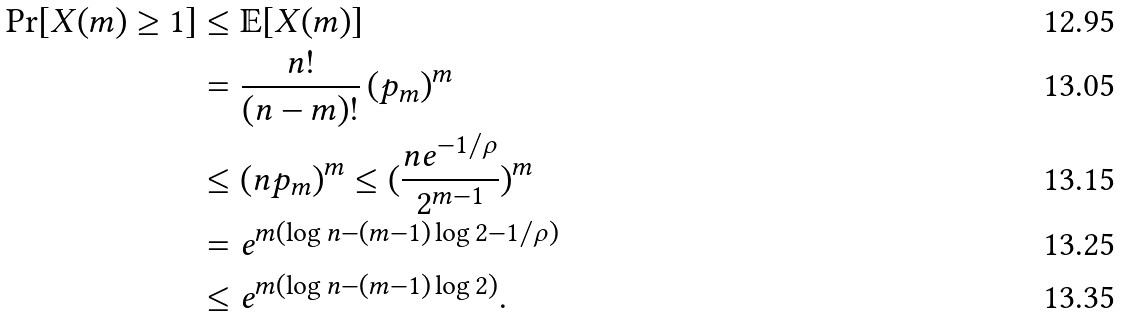Convert formula to latex. <formula><loc_0><loc_0><loc_500><loc_500>\Pr [ X ( m ) \geq 1 ] & \leq \mathbb { E } [ X ( m ) ] \\ & = \frac { n ! } { ( n - m ) ! } \, ( p _ { m } ) ^ { m } \\ & \leq ( n p _ { m } ) ^ { m } \leq ( \frac { n e ^ { - 1 / \rho } } { 2 ^ { m - 1 } } ) ^ { m } \\ & = e ^ { m ( \log n - ( m - 1 ) \log 2 - 1 / \rho ) } \\ & \leq e ^ { m ( \log n - ( m - 1 ) \log 2 ) } .</formula> 